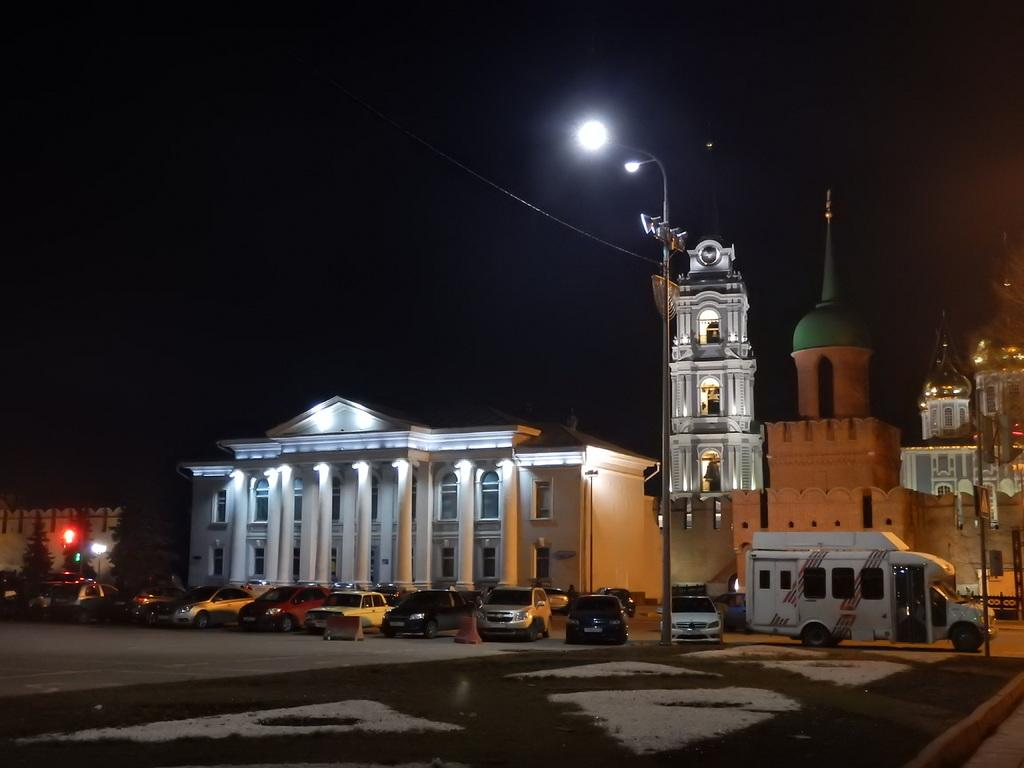What type of structure is present in the image? There is a building in the image. What other natural elements can be seen in the image? There are trees in the image. What man-made objects are visible in the image? There are vehicles and a light pole in the image. What type of pathway is present in the image? There is a road in the image. What can be seen in the background of the image? The sky is visible in the background of the image. What type of education is being offered at the building in the image? The image does not provide any information about the type of education offered at the building. What type of apparel is being sold at the light pole in the image? There is no indication of any apparel being sold at the light pole in the image. 